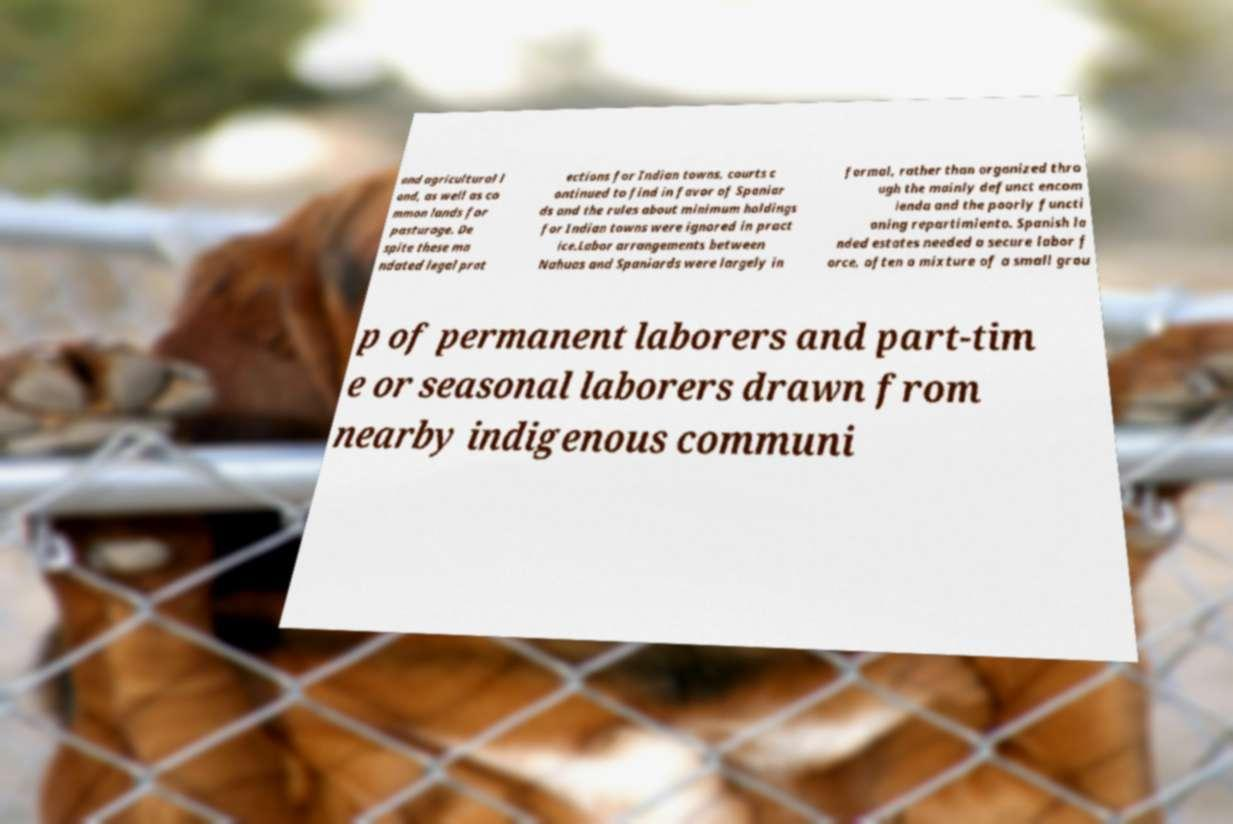Could you extract and type out the text from this image? and agricultural l and, as well as co mmon lands for pasturage. De spite these ma ndated legal prot ections for Indian towns, courts c ontinued to find in favor of Spaniar ds and the rules about minimum holdings for Indian towns were ignored in pract ice.Labor arrangements between Nahuas and Spaniards were largely in formal, rather than organized thro ugh the mainly defunct encom ienda and the poorly functi oning repartimiento. Spanish la nded estates needed a secure labor f orce, often a mixture of a small grou p of permanent laborers and part-tim e or seasonal laborers drawn from nearby indigenous communi 